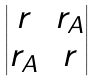Convert formula to latex. <formula><loc_0><loc_0><loc_500><loc_500>\begin{vmatrix} r & r _ { A } \\ r _ { A } & r \end{vmatrix}</formula> 